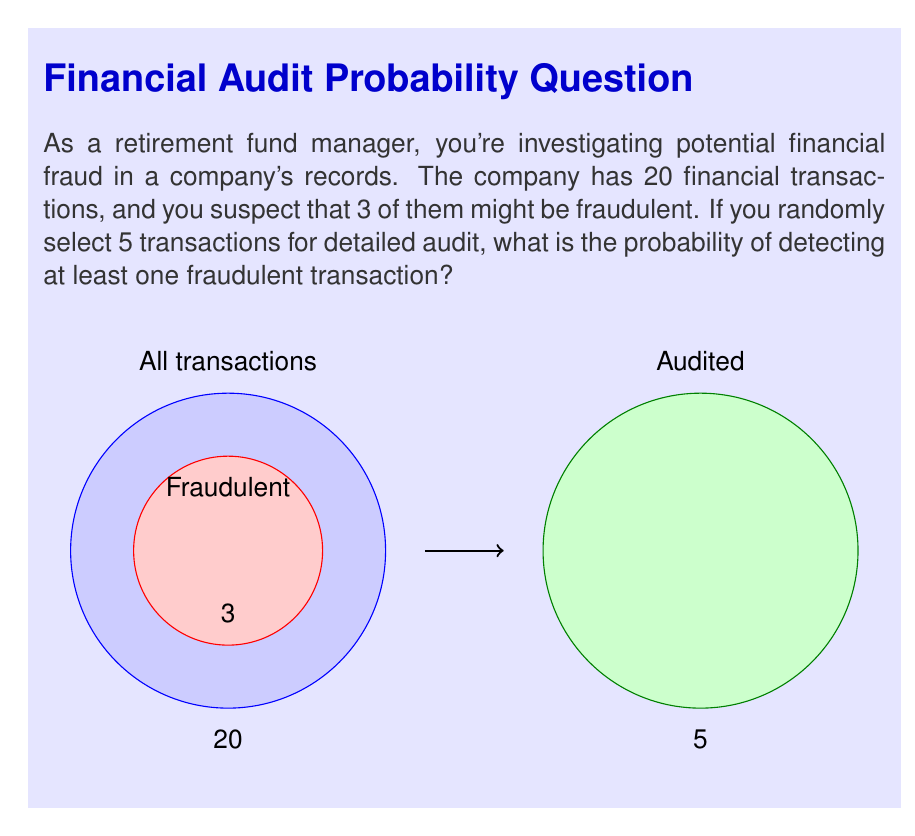Give your solution to this math problem. Let's approach this step-by-step using combinatorial analysis:

1) First, we need to calculate the total number of ways to select 5 transactions out of 20. This is given by the combination formula:

   $$\binom{20}{5} = \frac{20!}{5!(20-5)!} = \frac{20!}{5!15!} = 15,504$$

2) Now, we need to calculate the number of ways to select 5 transactions without any fraudulent ones. This is equivalent to selecting 5 out of the 17 non-fraudulent transactions:

   $$\binom{17}{5} = \frac{16!}{5!(17-5)!} = \frac{17!}{5!12!} = 6,188$$

3) The probability of detecting at least one fraudulent transaction is the complement of the probability of selecting no fraudulent transactions. So:

   $$P(\text{at least one fraudulent}) = 1 - P(\text{no fraudulent})$$

4) The probability of selecting no fraudulent transactions is:

   $$P(\text{no fraudulent}) = \frac{\binom{17}{5}}{\binom{20}{5}} = \frac{6,188}{15,504} = 0.3991$$

5) Therefore, the probability of detecting at least one fraudulent transaction is:

   $$P(\text{at least one fraudulent}) = 1 - 0.3991 = 0.6009$$
Answer: $0.6009$ or $60.09\%$ 